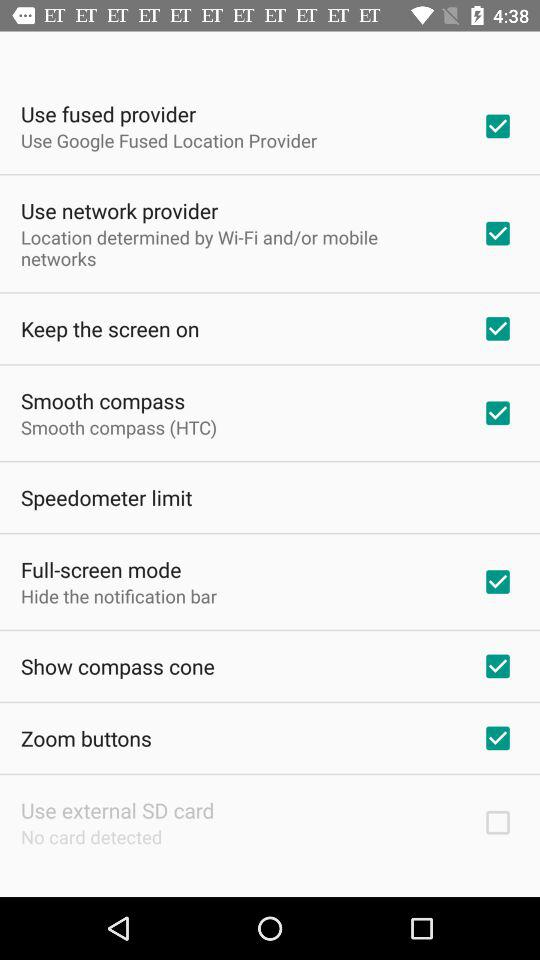What's the status of the "Zoom buttons"? The status is "on". 